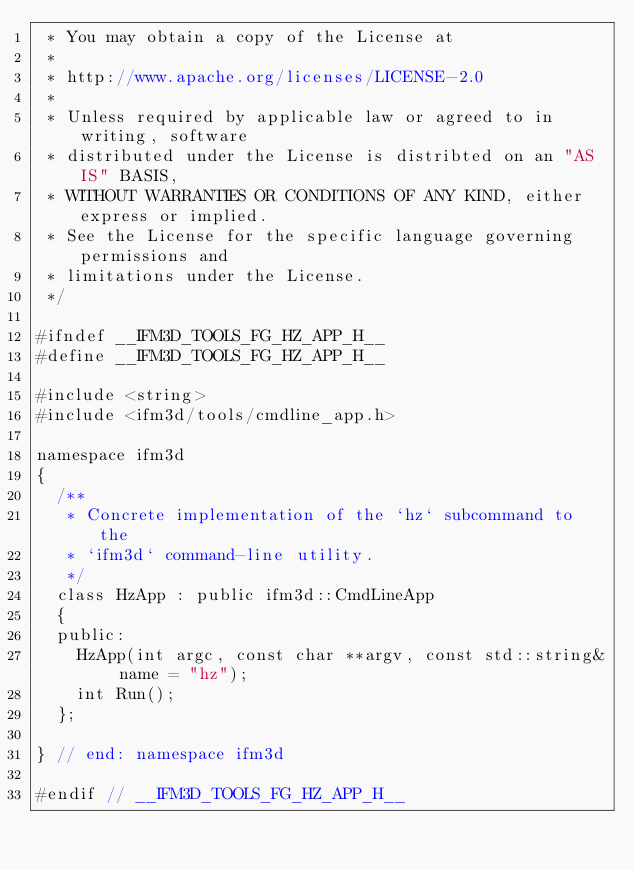<code> <loc_0><loc_0><loc_500><loc_500><_C_> * You may obtain a copy of the License at
 *
 * http://www.apache.org/licenses/LICENSE-2.0
 *
 * Unless required by applicable law or agreed to in writing, software
 * distributed under the License is distribted on an "AS IS" BASIS,
 * WITHOUT WARRANTIES OR CONDITIONS OF ANY KIND, either express or implied.
 * See the License for the specific language governing permissions and
 * limitations under the License.
 */

#ifndef __IFM3D_TOOLS_FG_HZ_APP_H__
#define __IFM3D_TOOLS_FG_HZ_APP_H__

#include <string>
#include <ifm3d/tools/cmdline_app.h>

namespace ifm3d
{
  /**
   * Concrete implementation of the `hz` subcommand to the
   * `ifm3d` command-line utility.
   */
  class HzApp : public ifm3d::CmdLineApp
  {
  public:
    HzApp(int argc, const char **argv, const std::string& name = "hz");
    int Run();
  };

} // end: namespace ifm3d

#endif // __IFM3D_TOOLS_FG_HZ_APP_H__
</code> 